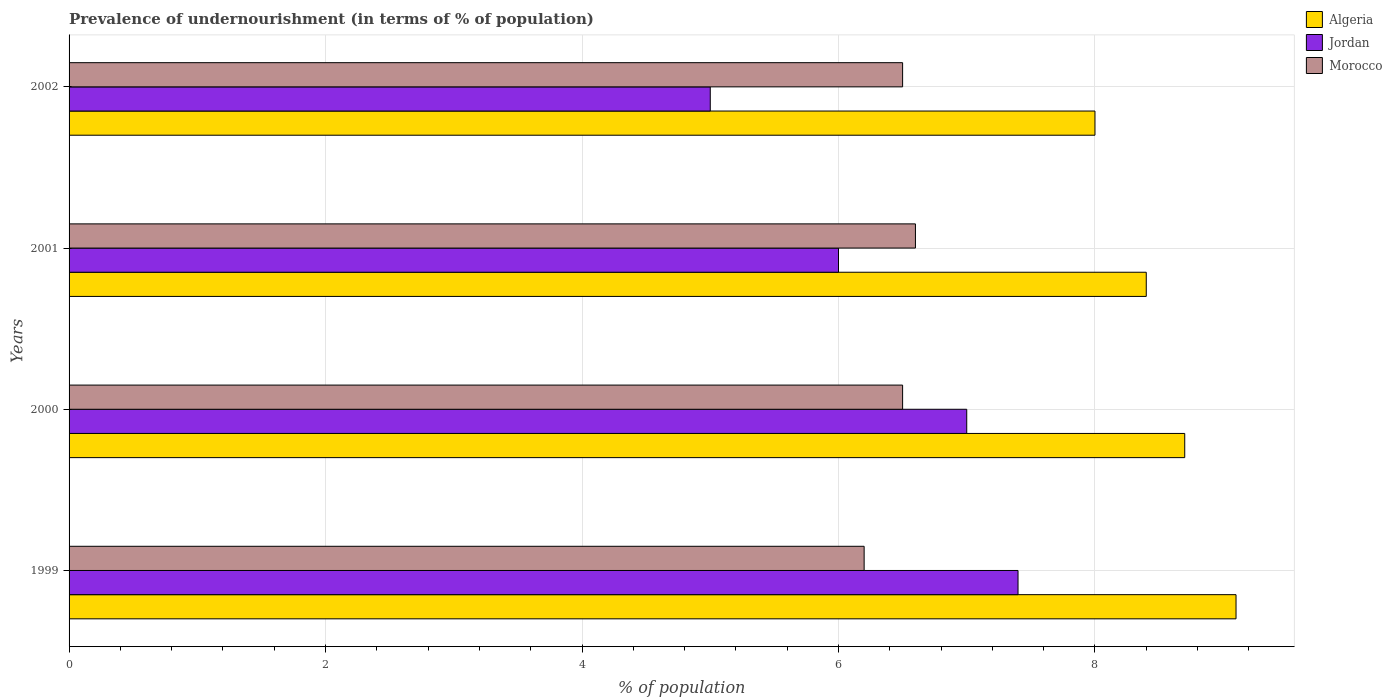How many different coloured bars are there?
Offer a terse response. 3. How many groups of bars are there?
Your response must be concise. 4. Are the number of bars per tick equal to the number of legend labels?
Your answer should be compact. Yes. What is the label of the 2nd group of bars from the top?
Provide a succinct answer. 2001. What is the percentage of undernourished population in Morocco in 1999?
Ensure brevity in your answer.  6.2. Across all years, what is the maximum percentage of undernourished population in Morocco?
Provide a short and direct response. 6.6. Across all years, what is the minimum percentage of undernourished population in Algeria?
Offer a very short reply. 8. In which year was the percentage of undernourished population in Jordan maximum?
Ensure brevity in your answer.  1999. What is the total percentage of undernourished population in Morocco in the graph?
Offer a very short reply. 25.8. What is the difference between the percentage of undernourished population in Morocco in 1999 and that in 2001?
Offer a terse response. -0.4. What is the difference between the percentage of undernourished population in Morocco in 2000 and the percentage of undernourished population in Algeria in 2001?
Your answer should be compact. -1.9. What is the average percentage of undernourished population in Jordan per year?
Keep it short and to the point. 6.35. In how many years, is the percentage of undernourished population in Jordan greater than 0.8 %?
Your answer should be compact. 4. What is the ratio of the percentage of undernourished population in Algeria in 2000 to that in 2002?
Your response must be concise. 1.09. Is the percentage of undernourished population in Morocco in 2000 less than that in 2002?
Offer a very short reply. No. Is the difference between the percentage of undernourished population in Morocco in 2000 and 2001 greater than the difference between the percentage of undernourished population in Jordan in 2000 and 2001?
Offer a very short reply. No. What is the difference between the highest and the second highest percentage of undernourished population in Morocco?
Your response must be concise. 0.1. What is the difference between the highest and the lowest percentage of undernourished population in Jordan?
Offer a terse response. 2.4. In how many years, is the percentage of undernourished population in Morocco greater than the average percentage of undernourished population in Morocco taken over all years?
Make the answer very short. 3. Is the sum of the percentage of undernourished population in Algeria in 1999 and 2001 greater than the maximum percentage of undernourished population in Jordan across all years?
Your answer should be compact. Yes. What does the 1st bar from the top in 1999 represents?
Provide a short and direct response. Morocco. What does the 1st bar from the bottom in 2000 represents?
Your answer should be compact. Algeria. How many bars are there?
Make the answer very short. 12. What is the difference between two consecutive major ticks on the X-axis?
Keep it short and to the point. 2. Does the graph contain grids?
Ensure brevity in your answer.  Yes. How are the legend labels stacked?
Keep it short and to the point. Vertical. What is the title of the graph?
Keep it short and to the point. Prevalence of undernourishment (in terms of % of population). What is the label or title of the X-axis?
Make the answer very short. % of population. What is the label or title of the Y-axis?
Give a very brief answer. Years. What is the % of population of Algeria in 1999?
Give a very brief answer. 9.1. What is the % of population of Algeria in 2000?
Give a very brief answer. 8.7. What is the % of population of Jordan in 2000?
Keep it short and to the point. 7. What is the % of population of Morocco in 2000?
Keep it short and to the point. 6.5. What is the % of population in Algeria in 2001?
Your answer should be very brief. 8.4. What is the % of population in Jordan in 2001?
Provide a succinct answer. 6. What is the % of population of Morocco in 2001?
Provide a short and direct response. 6.6. What is the % of population of Jordan in 2002?
Offer a very short reply. 5. Across all years, what is the minimum % of population of Jordan?
Make the answer very short. 5. Across all years, what is the minimum % of population of Morocco?
Make the answer very short. 6.2. What is the total % of population in Algeria in the graph?
Give a very brief answer. 34.2. What is the total % of population in Jordan in the graph?
Offer a terse response. 25.4. What is the total % of population in Morocco in the graph?
Your response must be concise. 25.8. What is the difference between the % of population of Algeria in 1999 and that in 2000?
Your answer should be compact. 0.4. What is the difference between the % of population of Jordan in 1999 and that in 2001?
Your response must be concise. 1.4. What is the difference between the % of population in Morocco in 1999 and that in 2001?
Ensure brevity in your answer.  -0.4. What is the difference between the % of population of Jordan in 1999 and that in 2002?
Give a very brief answer. 2.4. What is the difference between the % of population in Morocco in 1999 and that in 2002?
Provide a short and direct response. -0.3. What is the difference between the % of population of Jordan in 2000 and that in 2001?
Keep it short and to the point. 1. What is the difference between the % of population of Morocco in 2000 and that in 2001?
Ensure brevity in your answer.  -0.1. What is the difference between the % of population in Algeria in 2000 and that in 2002?
Ensure brevity in your answer.  0.7. What is the difference between the % of population in Morocco in 2000 and that in 2002?
Ensure brevity in your answer.  0. What is the difference between the % of population in Algeria in 2001 and that in 2002?
Offer a very short reply. 0.4. What is the difference between the % of population in Algeria in 1999 and the % of population in Jordan in 2000?
Give a very brief answer. 2.1. What is the difference between the % of population of Jordan in 1999 and the % of population of Morocco in 2000?
Make the answer very short. 0.9. What is the difference between the % of population in Algeria in 1999 and the % of population in Jordan in 2002?
Provide a succinct answer. 4.1. What is the difference between the % of population of Jordan in 1999 and the % of population of Morocco in 2002?
Make the answer very short. 0.9. What is the difference between the % of population of Algeria in 2000 and the % of population of Jordan in 2001?
Provide a short and direct response. 2.7. What is the difference between the % of population in Algeria in 2000 and the % of population in Morocco in 2001?
Offer a terse response. 2.1. What is the difference between the % of population in Algeria in 2000 and the % of population in Morocco in 2002?
Your response must be concise. 2.2. What is the difference between the % of population of Jordan in 2000 and the % of population of Morocco in 2002?
Give a very brief answer. 0.5. What is the difference between the % of population of Algeria in 2001 and the % of population of Morocco in 2002?
Provide a succinct answer. 1.9. What is the difference between the % of population in Jordan in 2001 and the % of population in Morocco in 2002?
Offer a very short reply. -0.5. What is the average % of population in Algeria per year?
Your answer should be very brief. 8.55. What is the average % of population of Jordan per year?
Offer a very short reply. 6.35. What is the average % of population of Morocco per year?
Make the answer very short. 6.45. In the year 1999, what is the difference between the % of population of Algeria and % of population of Morocco?
Provide a succinct answer. 2.9. In the year 2000, what is the difference between the % of population of Algeria and % of population of Morocco?
Provide a short and direct response. 2.2. In the year 2001, what is the difference between the % of population in Algeria and % of population in Jordan?
Give a very brief answer. 2.4. In the year 2001, what is the difference between the % of population in Jordan and % of population in Morocco?
Offer a very short reply. -0.6. What is the ratio of the % of population in Algeria in 1999 to that in 2000?
Offer a very short reply. 1.05. What is the ratio of the % of population of Jordan in 1999 to that in 2000?
Your answer should be very brief. 1.06. What is the ratio of the % of population of Morocco in 1999 to that in 2000?
Offer a very short reply. 0.95. What is the ratio of the % of population of Algeria in 1999 to that in 2001?
Your answer should be very brief. 1.08. What is the ratio of the % of population of Jordan in 1999 to that in 2001?
Keep it short and to the point. 1.23. What is the ratio of the % of population in Morocco in 1999 to that in 2001?
Provide a short and direct response. 0.94. What is the ratio of the % of population in Algeria in 1999 to that in 2002?
Your answer should be very brief. 1.14. What is the ratio of the % of population in Jordan in 1999 to that in 2002?
Ensure brevity in your answer.  1.48. What is the ratio of the % of population of Morocco in 1999 to that in 2002?
Make the answer very short. 0.95. What is the ratio of the % of population in Algeria in 2000 to that in 2001?
Make the answer very short. 1.04. What is the ratio of the % of population of Morocco in 2000 to that in 2001?
Give a very brief answer. 0.98. What is the ratio of the % of population in Algeria in 2000 to that in 2002?
Make the answer very short. 1.09. What is the ratio of the % of population of Morocco in 2000 to that in 2002?
Your answer should be compact. 1. What is the ratio of the % of population in Algeria in 2001 to that in 2002?
Provide a short and direct response. 1.05. What is the ratio of the % of population in Jordan in 2001 to that in 2002?
Your answer should be very brief. 1.2. What is the ratio of the % of population of Morocco in 2001 to that in 2002?
Provide a short and direct response. 1.02. What is the difference between the highest and the second highest % of population of Jordan?
Ensure brevity in your answer.  0.4. What is the difference between the highest and the lowest % of population of Algeria?
Your response must be concise. 1.1. 